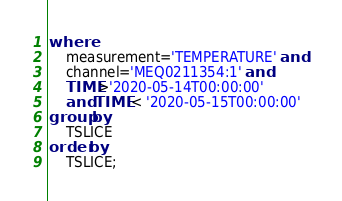Convert code to text. <code><loc_0><loc_0><loc_500><loc_500><_SQL_>where 
    measurement='TEMPERATURE' and 
    channel='MEQ0211354:1' and 
    TIME>'2020-05-14T00:00:00'
    and TIME < '2020-05-15T00:00:00'
group by 
    TSLICE
order by 
    TSLICE;</code> 